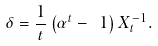<formula> <loc_0><loc_0><loc_500><loc_500>\delta = \frac { 1 } { t } \left ( \alpha ^ { t } - \ 1 \right ) X _ { t } ^ { - 1 } .</formula> 